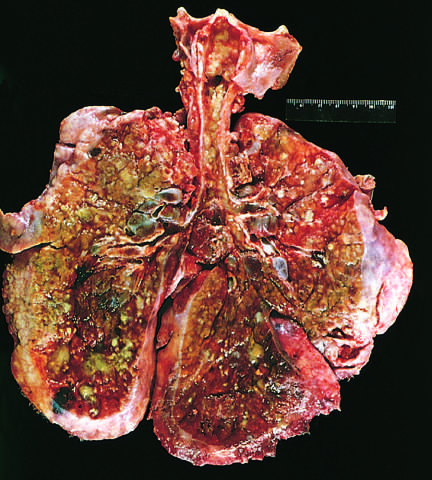what is consolidated by a combination of both secretions and pneumonia?
Answer the question using a single word or phrase. The pulmonary parenchyma 